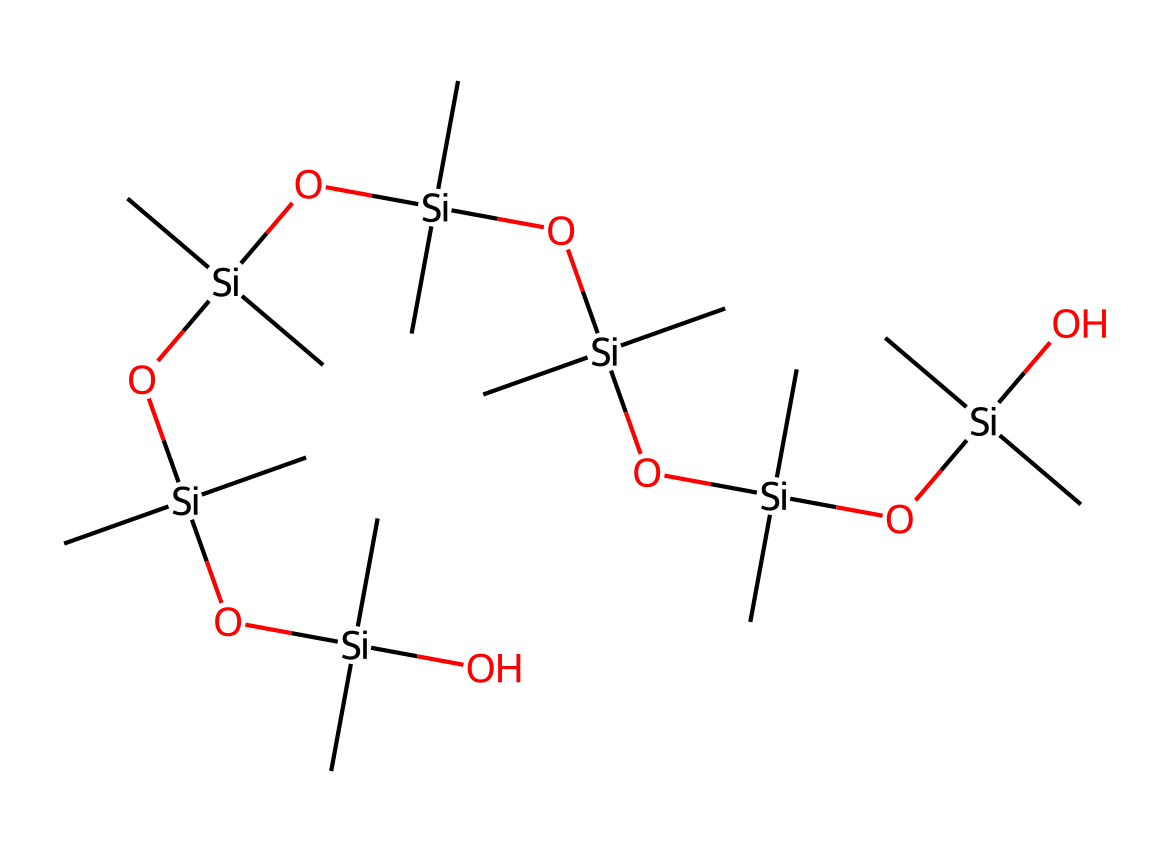What is the main element in the silicone structure? The structure contains silicon atoms as the primary component, which is evident in its backbone where silicon atoms are connected to oxygen and carbon atoms.
Answer: silicon How many silicon atoms are present in the chemical? By analyzing the provided SMILES notation, we can count that there are five silicon atoms, indicated by the multiple occurrences of the silicon symbol 'Si'.
Answer: five What type of functional groups are attached to the silicone framework? The structure includes hydroxyl (-OH) and alkyl (-(C)(C)) groups, as seen from the presence of 'O' and carbon attachments in the SMILES.
Answer: hydroxyl and alkyl How many hydroxyl groups are in the chemical? Examining the chemical structure closely, we see that there are six hydroxyl groups indicated by the oxygen atoms connected to silicon atoms, confirming the presence of alcohol groups.
Answer: six What type of bond connects silicon and oxygen in this compound? The link between silicon and oxygen atoms is primarily covalent bonding, which is typical for organosilicon compounds as they form strong bonds.
Answer: covalent What role do the alkyl groups play in the performance of this coating? Alkyl groups provide hydrophobic properties that enhance the coating's resistance to water and dirt, making the surface smoother and easier to clean.
Answer: hydrophobic properties How does the presence of multiple silicons affect the durability of the coating? Multiple silicon atoms in the structure can create a cross-linked network, which improves the overall strength and durability of the coating against environmental conditions.
Answer: cross-linked network 